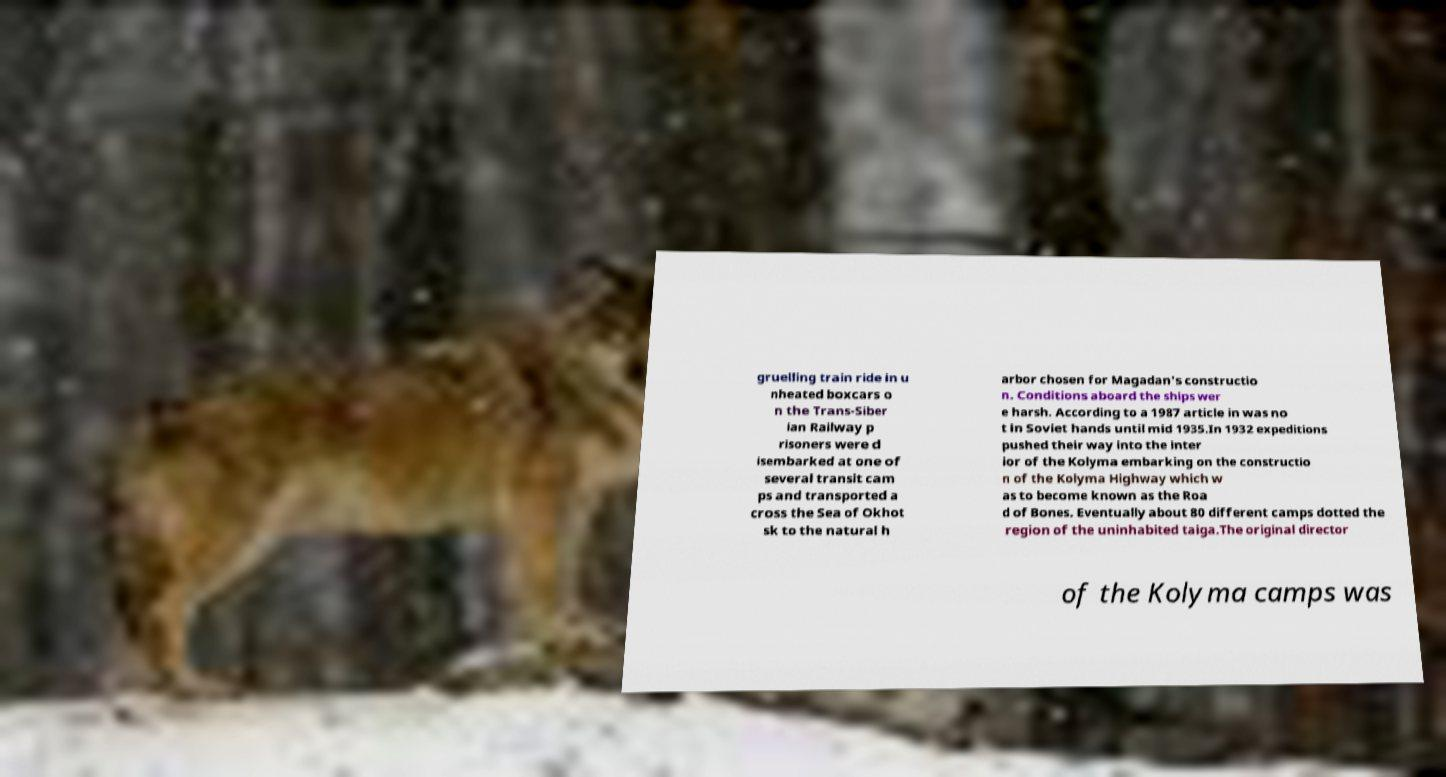There's text embedded in this image that I need extracted. Can you transcribe it verbatim? gruelling train ride in u nheated boxcars o n the Trans-Siber ian Railway p risoners were d isembarked at one of several transit cam ps and transported a cross the Sea of Okhot sk to the natural h arbor chosen for Magadan's constructio n. Conditions aboard the ships wer e harsh. According to a 1987 article in was no t in Soviet hands until mid 1935.In 1932 expeditions pushed their way into the inter ior of the Kolyma embarking on the constructio n of the Kolyma Highway which w as to become known as the Roa d of Bones. Eventually about 80 different camps dotted the region of the uninhabited taiga.The original director of the Kolyma camps was 